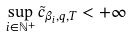Convert formula to latex. <formula><loc_0><loc_0><loc_500><loc_500>\sup _ { i \in \mathbb { N } ^ { + } } \tilde { c } _ { \beta _ { i } , q , T } < + \infty</formula> 